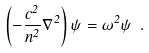<formula> <loc_0><loc_0><loc_500><loc_500>\left ( - \frac { c ^ { 2 } } { n ^ { 2 } } \nabla ^ { 2 } \right ) \psi = \omega ^ { 2 } \psi \ .</formula> 